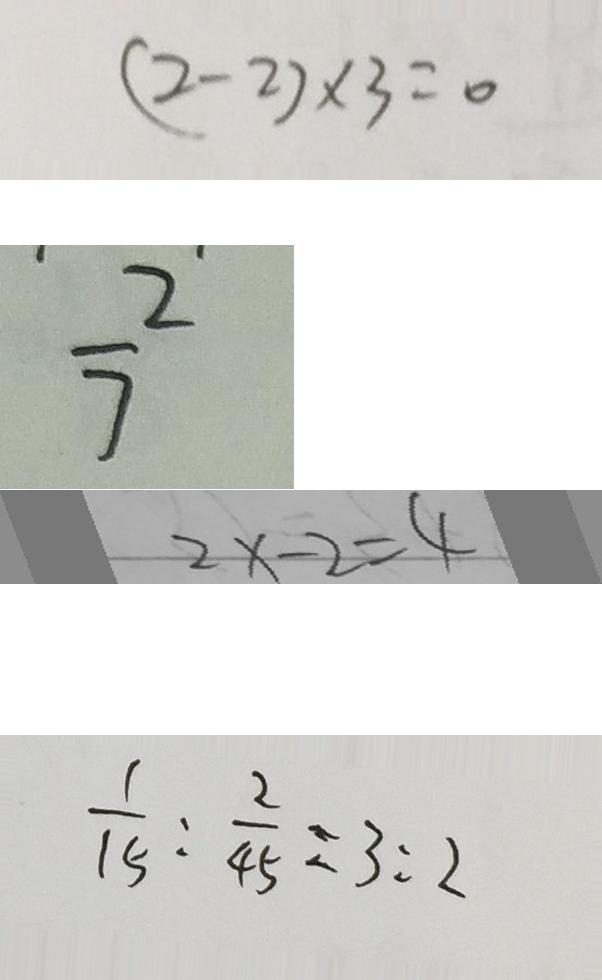<formula> <loc_0><loc_0><loc_500><loc_500>( 2 - 2 ) \times 3 = 0 
 \frac { 2 } { 7 } 
 2 x - 2 = 4 
 \frac { 1 } { 1 5 } : \frac { 2 } { 4 5 } = 3 : 2</formula> 